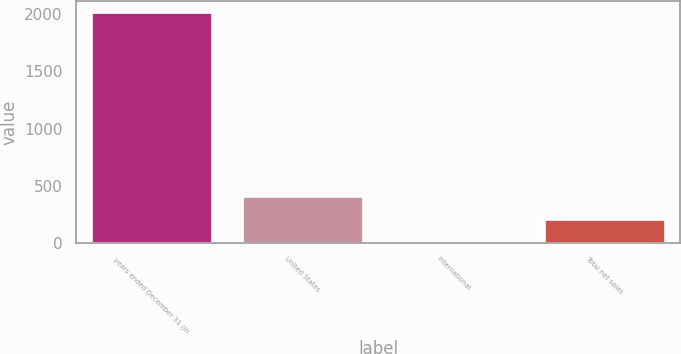Convert chart to OTSL. <chart><loc_0><loc_0><loc_500><loc_500><bar_chart><fcel>years ended December 31 (in<fcel>United States<fcel>International<fcel>Total net sales<nl><fcel>2017<fcel>405<fcel>2<fcel>203.5<nl></chart> 